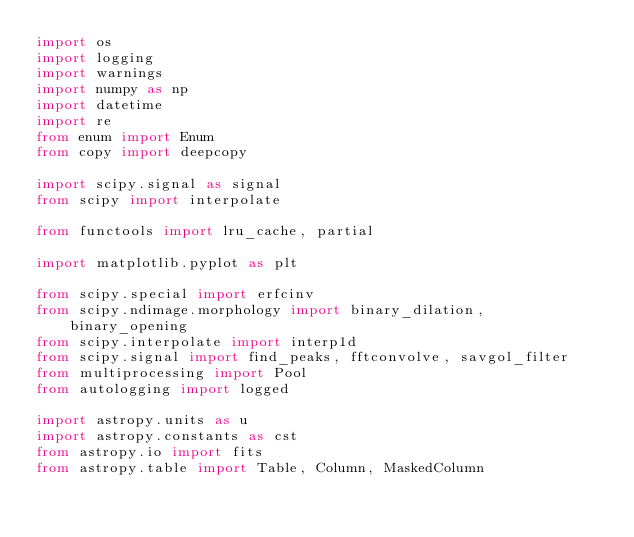Convert code to text. <code><loc_0><loc_0><loc_500><loc_500><_Python_>import os
import logging
import warnings
import numpy as np
import datetime
import re
from enum import Enum
from copy import deepcopy

import scipy.signal as signal
from scipy import interpolate

from functools import lru_cache, partial

import matplotlib.pyplot as plt

from scipy.special import erfcinv
from scipy.ndimage.morphology import binary_dilation, binary_opening
from scipy.interpolate import interp1d
from scipy.signal import find_peaks, fftconvolve, savgol_filter
from multiprocessing import Pool
from autologging import logged

import astropy.units as u
import astropy.constants as cst
from astropy.io import fits
from astropy.table import Table, Column, MaskedColumn</code> 